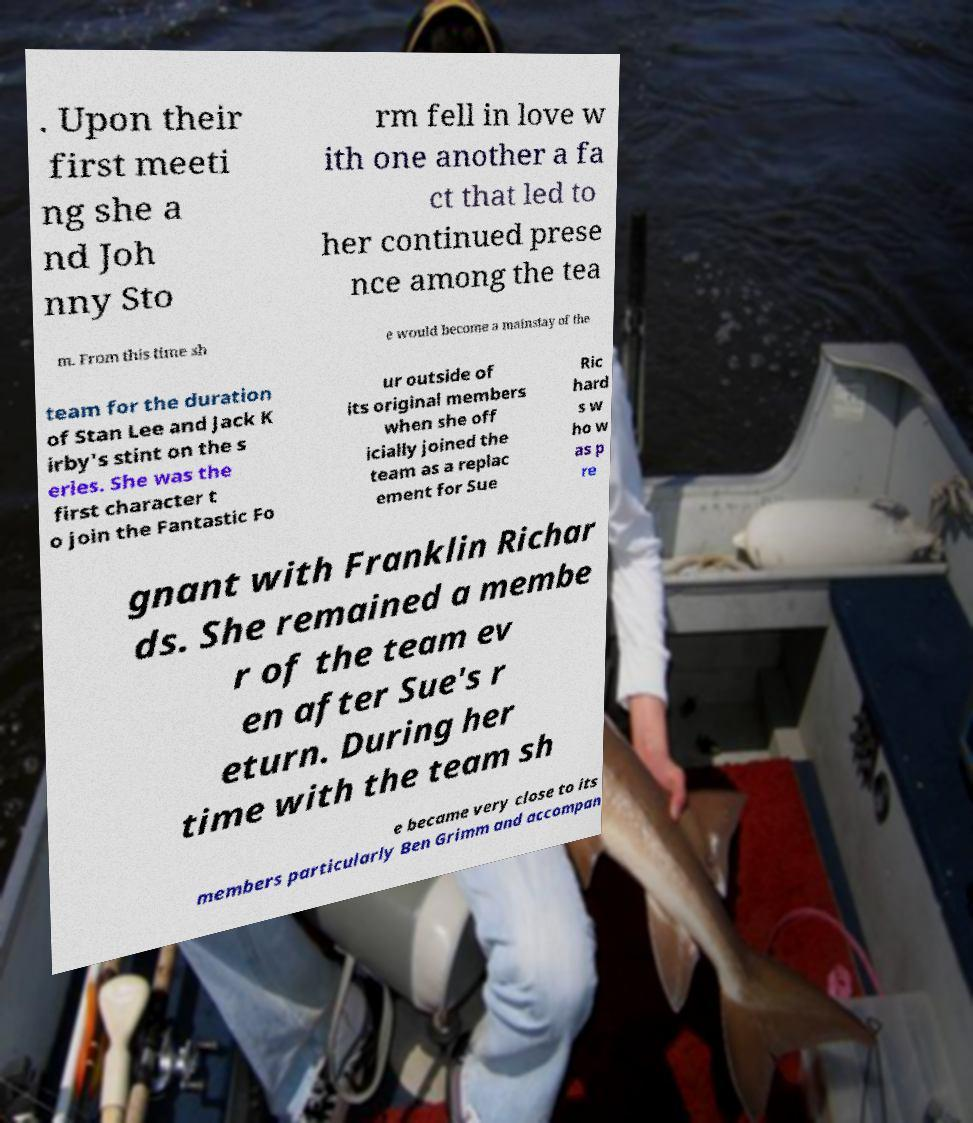I need the written content from this picture converted into text. Can you do that? . Upon their first meeti ng she a nd Joh nny Sto rm fell in love w ith one another a fa ct that led to her continued prese nce among the tea m. From this time sh e would become a mainstay of the team for the duration of Stan Lee and Jack K irby's stint on the s eries. She was the first character t o join the Fantastic Fo ur outside of its original members when she off icially joined the team as a replac ement for Sue Ric hard s w ho w as p re gnant with Franklin Richar ds. She remained a membe r of the team ev en after Sue's r eturn. During her time with the team sh e became very close to its members particularly Ben Grimm and accompan 